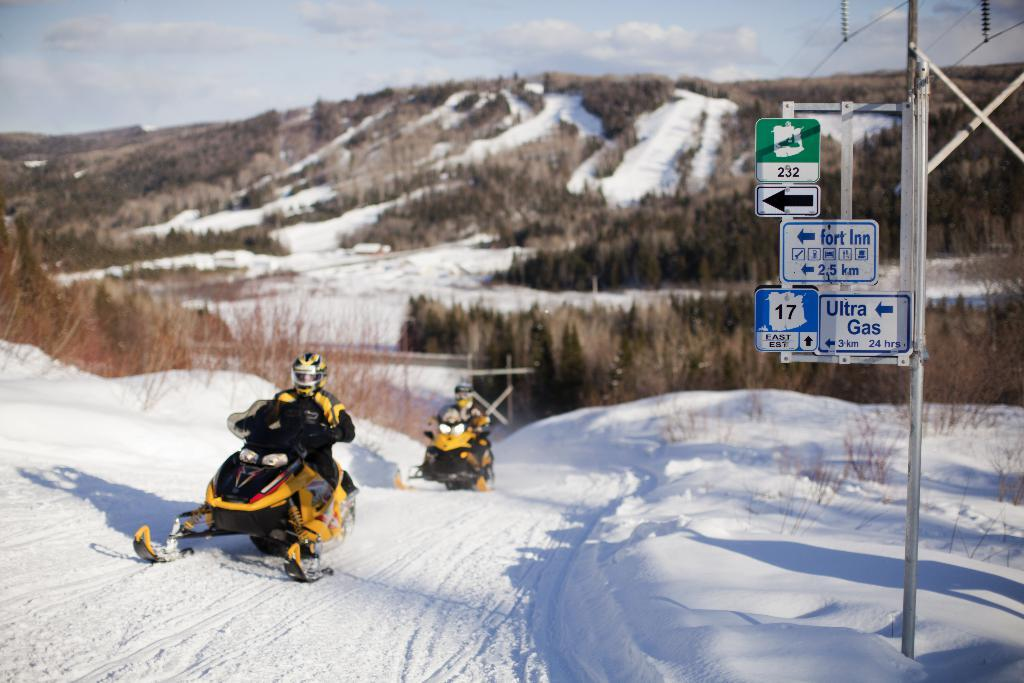What are the two persons doing in the image? The two persons are riding on a vehicle. What can be seen on the right side of the image? There is a sign board on the right side of the image. What is visible at the top of the image? The sky is visible at the top of the image. What type of landscape feature is present in the image? There is a hill in the image. What type of clam is being served at the restaurant in the image? There is no restaurant or clam present in the image. What is the governor doing in the image? There is no governor present in the image. 